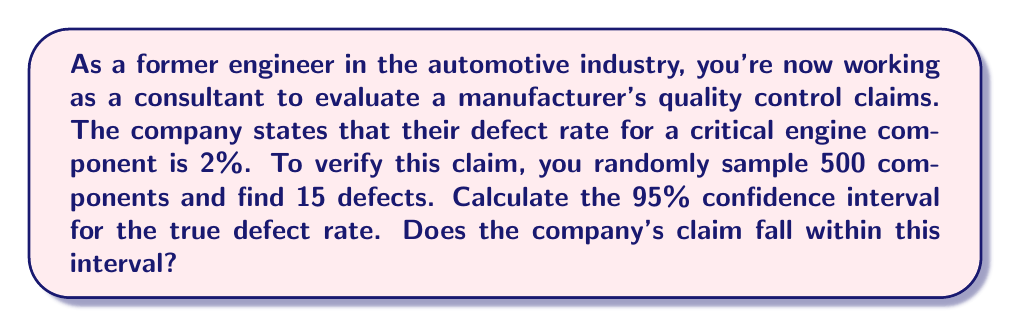Can you answer this question? Let's approach this step-by-step:

1) First, we need to calculate the sample proportion:
   $\hat{p} = \frac{\text{number of defects}}{\text{sample size}} = \frac{15}{500} = 0.03$ or 3%

2) The formula for the confidence interval of a proportion is:
   $$\hat{p} \pm z_{\alpha/2} \sqrt{\frac{\hat{p}(1-\hat{p})}{n}}$$
   where $z_{\alpha/2}$ is the critical value for the desired confidence level.

3) For a 95% confidence interval, $z_{\alpha/2} = 1.96$

4) Plugging in our values:
   $$0.03 \pm 1.96 \sqrt{\frac{0.03(1-0.03)}{500}}$$

5) Simplify:
   $$0.03 \pm 1.96 \sqrt{\frac{0.0291}{500}} = 0.03 \pm 1.96(0.00761) = 0.03 \pm 0.01492$$

6) Therefore, the 95% confidence interval is:
   $$(0.03 - 0.01492, 0.03 + 0.01492) = (0.01508, 0.04492)$$
   or (1.508%, 4.492%)

7) The company's claim of 2% falls within this interval, so we cannot reject their claim at the 95% confidence level.
Answer: 95% CI: (1.508%, 4.492%); Company's claim (2%) is within the interval. 